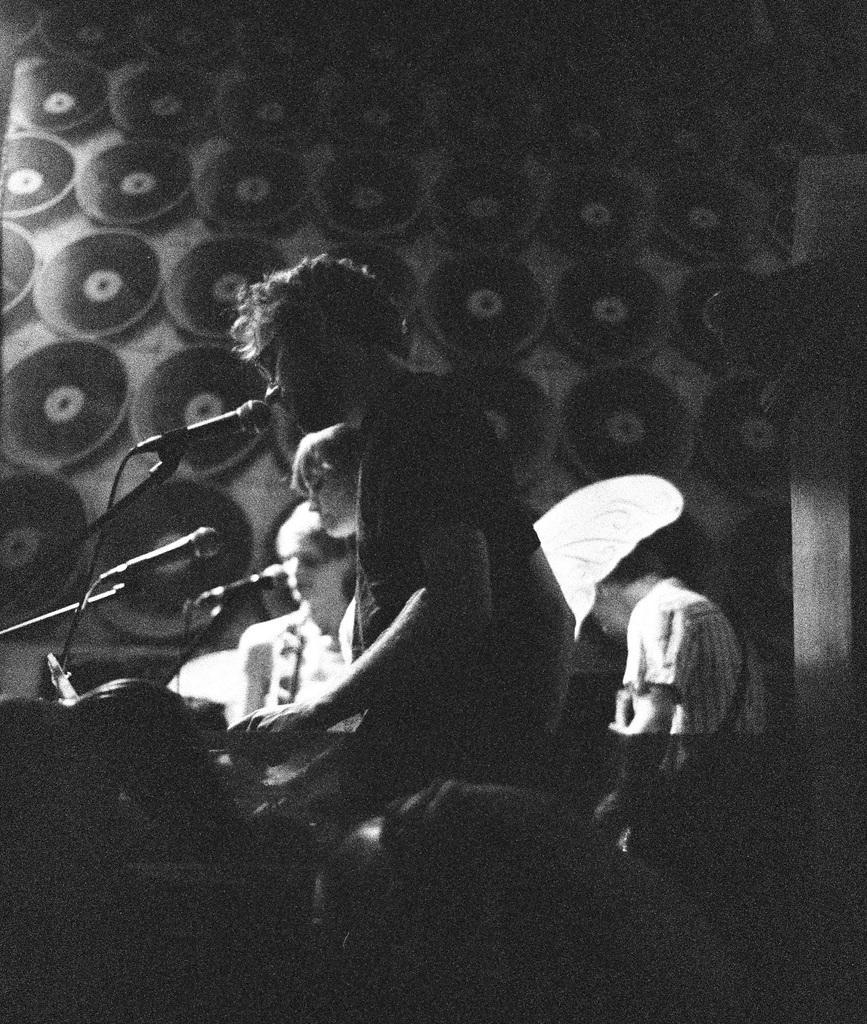Describe this image in one or two sentences. In this image there are people and we can see mics placed before them. At the bottom there is a band. In the background there is a wall. 